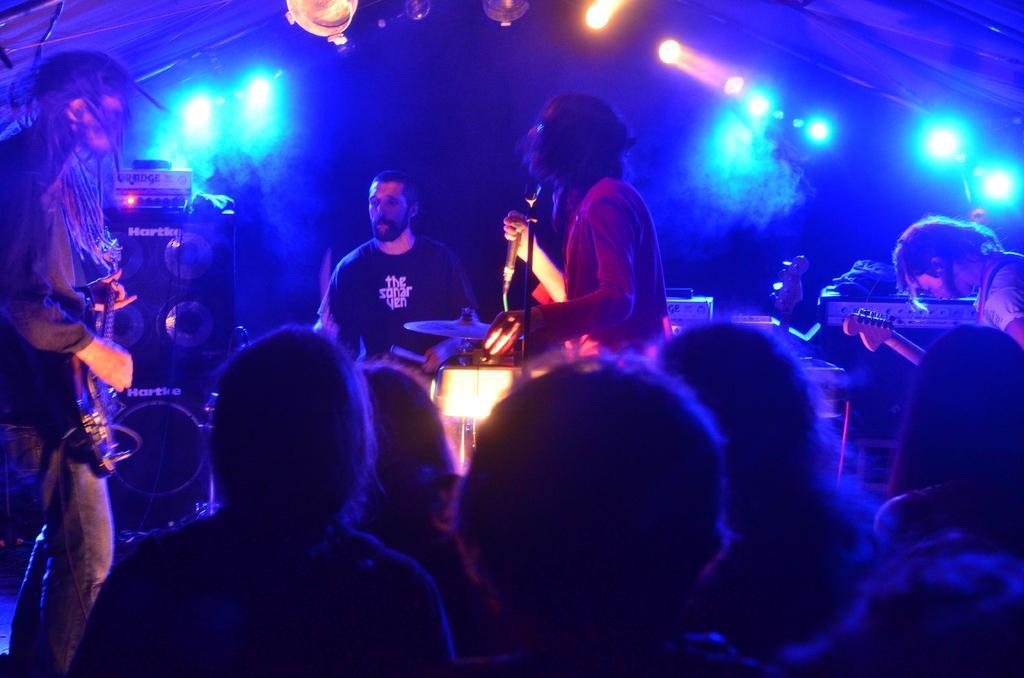In one or two sentences, can you explain what this image depicts? The image is from a concert. On the stage there are four people, on the center of the image a person is singing. In the background a person is playing drums. On the left a person is playing guitar. On the right another person is playing guitar. In the foreground in front of the stage there is crowd listening to the songs. In the background there are many lights. On the right side in the background there are speakers. 